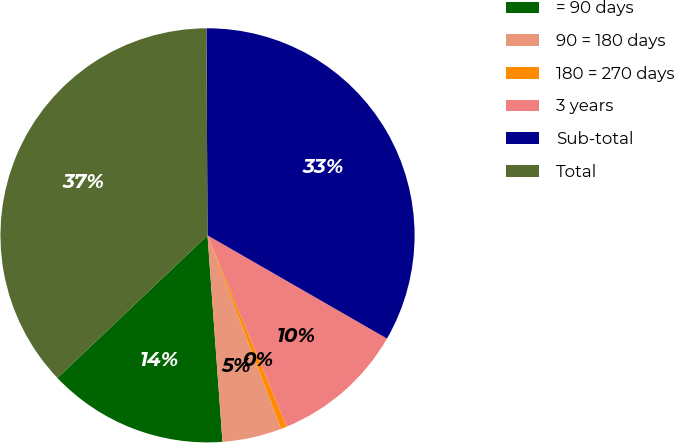Convert chart to OTSL. <chart><loc_0><loc_0><loc_500><loc_500><pie_chart><fcel>= 90 days<fcel>90 = 180 days<fcel>180 = 270 days<fcel>3 years<fcel>Sub-total<fcel>Total<nl><fcel>14.06%<fcel>4.63%<fcel>0.47%<fcel>10.44%<fcel>33.39%<fcel>37.01%<nl></chart> 